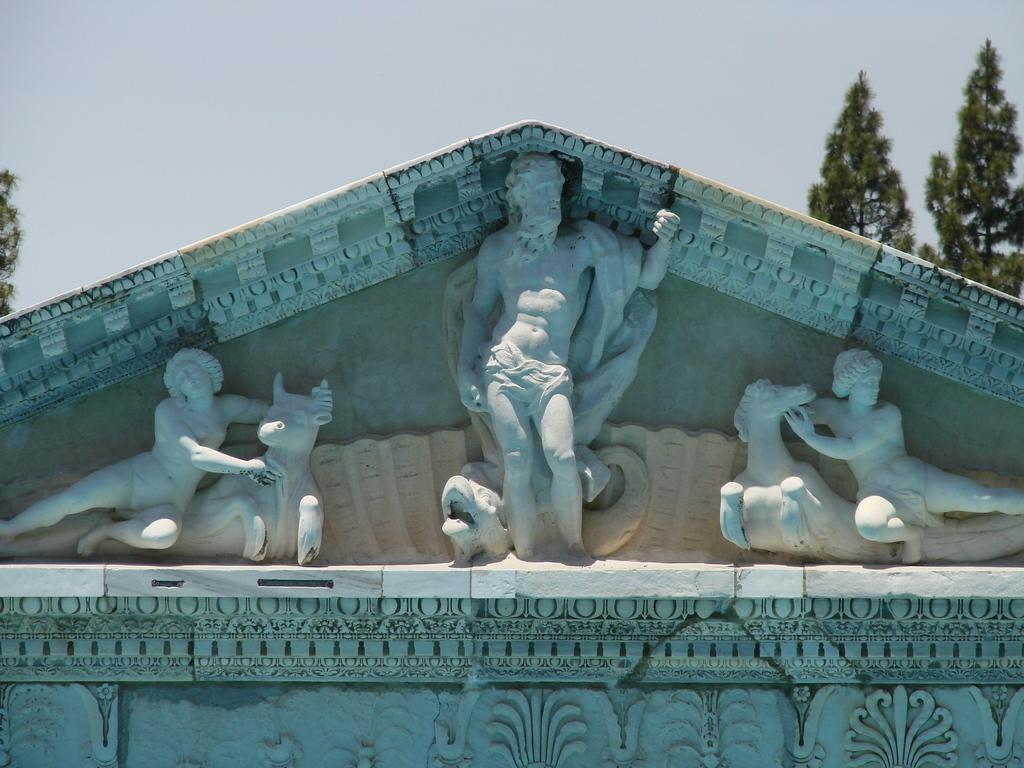Could you give a brief overview of what you see in this image? This is the picture of a building. There are sculptures on the wall. At the back there are trees. At the top there is sky. 